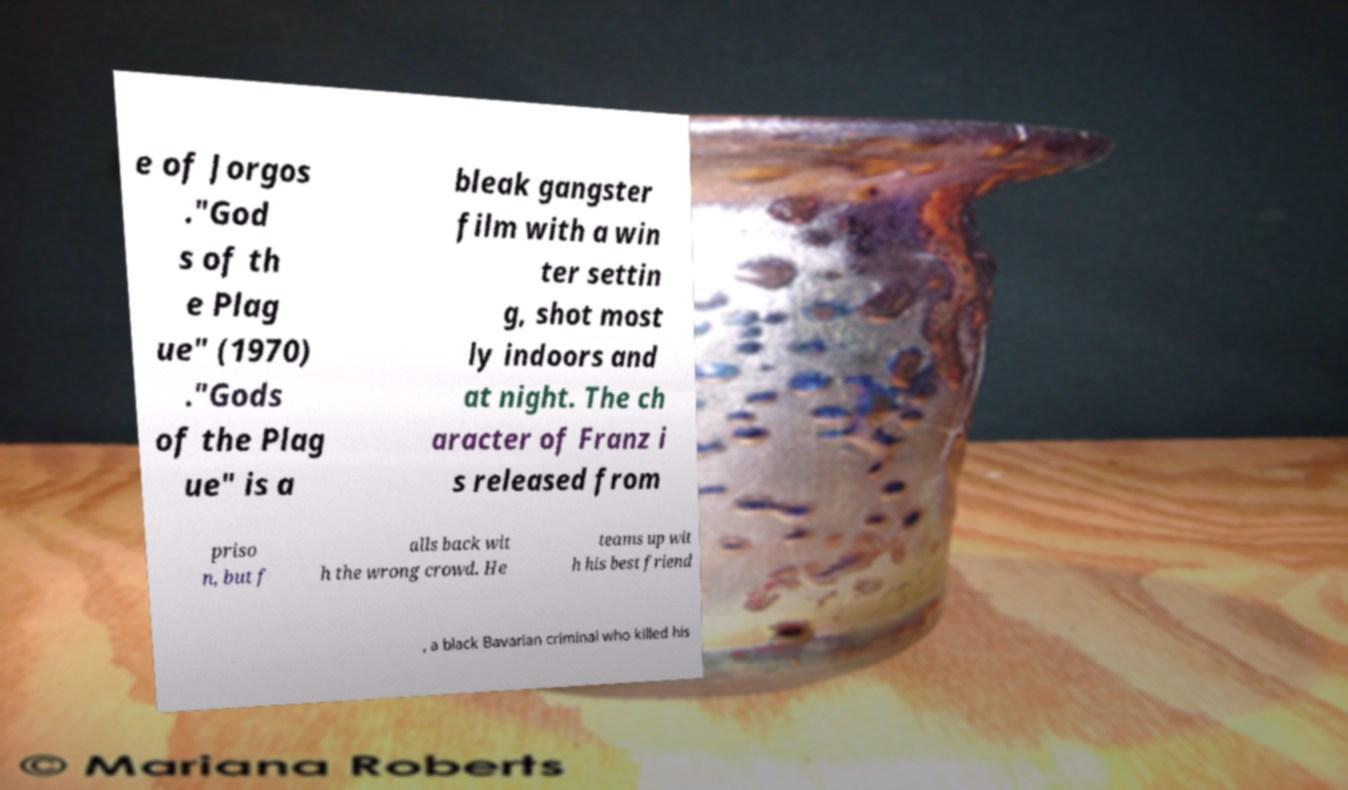What messages or text are displayed in this image? I need them in a readable, typed format. e of Jorgos ."God s of th e Plag ue" (1970) ."Gods of the Plag ue" is a bleak gangster film with a win ter settin g, shot most ly indoors and at night. The ch aracter of Franz i s released from priso n, but f alls back wit h the wrong crowd. He teams up wit h his best friend , a black Bavarian criminal who killed his 